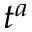Convert formula to latex. <formula><loc_0><loc_0><loc_500><loc_500>t ^ { a }</formula> 